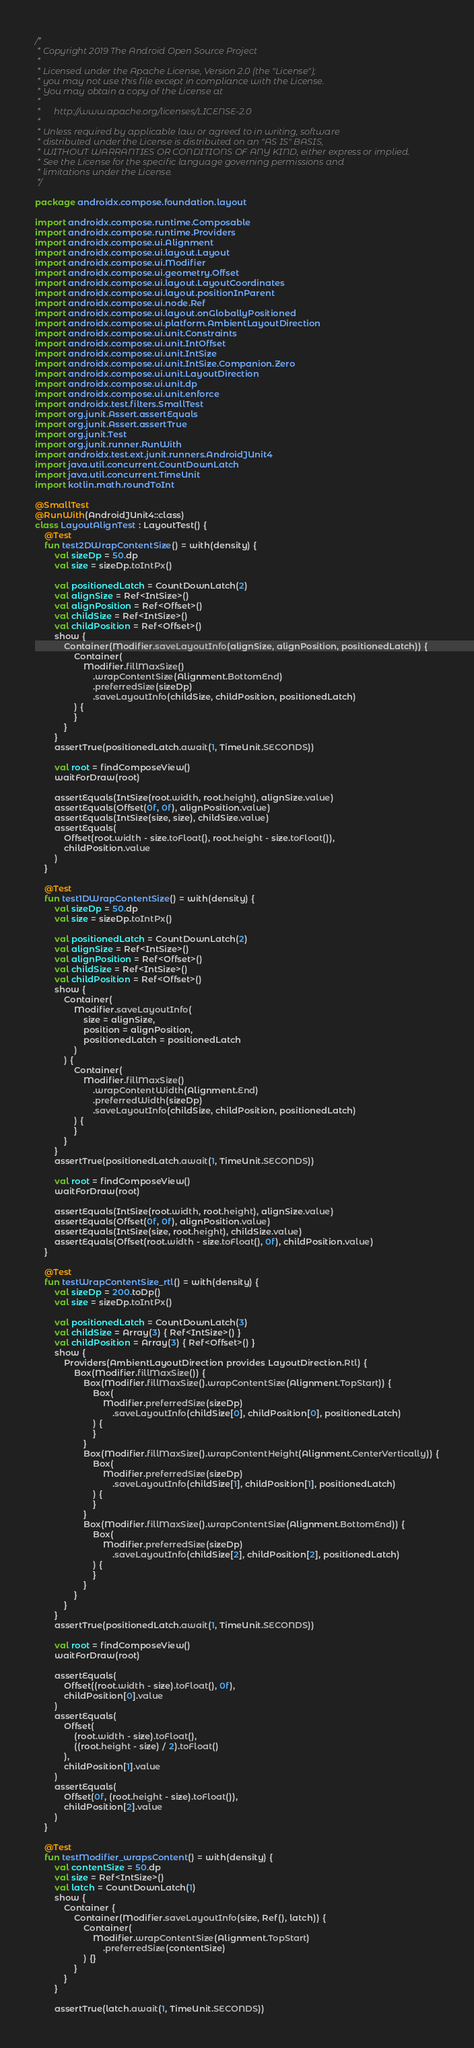<code> <loc_0><loc_0><loc_500><loc_500><_Kotlin_>/*
 * Copyright 2019 The Android Open Source Project
 *
 * Licensed under the Apache License, Version 2.0 (the "License");
 * you may not use this file except in compliance with the License.
 * You may obtain a copy of the License at
 *
 *      http://www.apache.org/licenses/LICENSE-2.0
 *
 * Unless required by applicable law or agreed to in writing, software
 * distributed under the License is distributed on an "AS IS" BASIS,
 * WITHOUT WARRANTIES OR CONDITIONS OF ANY KIND, either express or implied.
 * See the License for the specific language governing permissions and
 * limitations under the License.
 */

package androidx.compose.foundation.layout

import androidx.compose.runtime.Composable
import androidx.compose.runtime.Providers
import androidx.compose.ui.Alignment
import androidx.compose.ui.layout.Layout
import androidx.compose.ui.Modifier
import androidx.compose.ui.geometry.Offset
import androidx.compose.ui.layout.LayoutCoordinates
import androidx.compose.ui.layout.positionInParent
import androidx.compose.ui.node.Ref
import androidx.compose.ui.layout.onGloballyPositioned
import androidx.compose.ui.platform.AmbientLayoutDirection
import androidx.compose.ui.unit.Constraints
import androidx.compose.ui.unit.IntOffset
import androidx.compose.ui.unit.IntSize
import androidx.compose.ui.unit.IntSize.Companion.Zero
import androidx.compose.ui.unit.LayoutDirection
import androidx.compose.ui.unit.dp
import androidx.compose.ui.unit.enforce
import androidx.test.filters.SmallTest
import org.junit.Assert.assertEquals
import org.junit.Assert.assertTrue
import org.junit.Test
import org.junit.runner.RunWith
import androidx.test.ext.junit.runners.AndroidJUnit4
import java.util.concurrent.CountDownLatch
import java.util.concurrent.TimeUnit
import kotlin.math.roundToInt

@SmallTest
@RunWith(AndroidJUnit4::class)
class LayoutAlignTest : LayoutTest() {
    @Test
    fun test2DWrapContentSize() = with(density) {
        val sizeDp = 50.dp
        val size = sizeDp.toIntPx()

        val positionedLatch = CountDownLatch(2)
        val alignSize = Ref<IntSize>()
        val alignPosition = Ref<Offset>()
        val childSize = Ref<IntSize>()
        val childPosition = Ref<Offset>()
        show {
            Container(Modifier.saveLayoutInfo(alignSize, alignPosition, positionedLatch)) {
                Container(
                    Modifier.fillMaxSize()
                        .wrapContentSize(Alignment.BottomEnd)
                        .preferredSize(sizeDp)
                        .saveLayoutInfo(childSize, childPosition, positionedLatch)
                ) {
                }
            }
        }
        assertTrue(positionedLatch.await(1, TimeUnit.SECONDS))

        val root = findComposeView()
        waitForDraw(root)

        assertEquals(IntSize(root.width, root.height), alignSize.value)
        assertEquals(Offset(0f, 0f), alignPosition.value)
        assertEquals(IntSize(size, size), childSize.value)
        assertEquals(
            Offset(root.width - size.toFloat(), root.height - size.toFloat()),
            childPosition.value
        )
    }

    @Test
    fun test1DWrapContentSize() = with(density) {
        val sizeDp = 50.dp
        val size = sizeDp.toIntPx()

        val positionedLatch = CountDownLatch(2)
        val alignSize = Ref<IntSize>()
        val alignPosition = Ref<Offset>()
        val childSize = Ref<IntSize>()
        val childPosition = Ref<Offset>()
        show {
            Container(
                Modifier.saveLayoutInfo(
                    size = alignSize,
                    position = alignPosition,
                    positionedLatch = positionedLatch
                )
            ) {
                Container(
                    Modifier.fillMaxSize()
                        .wrapContentWidth(Alignment.End)
                        .preferredWidth(sizeDp)
                        .saveLayoutInfo(childSize, childPosition, positionedLatch)
                ) {
                }
            }
        }
        assertTrue(positionedLatch.await(1, TimeUnit.SECONDS))

        val root = findComposeView()
        waitForDraw(root)

        assertEquals(IntSize(root.width, root.height), alignSize.value)
        assertEquals(Offset(0f, 0f), alignPosition.value)
        assertEquals(IntSize(size, root.height), childSize.value)
        assertEquals(Offset(root.width - size.toFloat(), 0f), childPosition.value)
    }

    @Test
    fun testWrapContentSize_rtl() = with(density) {
        val sizeDp = 200.toDp()
        val size = sizeDp.toIntPx()

        val positionedLatch = CountDownLatch(3)
        val childSize = Array(3) { Ref<IntSize>() }
        val childPosition = Array(3) { Ref<Offset>() }
        show {
            Providers(AmbientLayoutDirection provides LayoutDirection.Rtl) {
                Box(Modifier.fillMaxSize()) {
                    Box(Modifier.fillMaxSize().wrapContentSize(Alignment.TopStart)) {
                        Box(
                            Modifier.preferredSize(sizeDp)
                                .saveLayoutInfo(childSize[0], childPosition[0], positionedLatch)
                        ) {
                        }
                    }
                    Box(Modifier.fillMaxSize().wrapContentHeight(Alignment.CenterVertically)) {
                        Box(
                            Modifier.preferredSize(sizeDp)
                                .saveLayoutInfo(childSize[1], childPosition[1], positionedLatch)
                        ) {
                        }
                    }
                    Box(Modifier.fillMaxSize().wrapContentSize(Alignment.BottomEnd)) {
                        Box(
                            Modifier.preferredSize(sizeDp)
                                .saveLayoutInfo(childSize[2], childPosition[2], positionedLatch)
                        ) {
                        }
                    }
                }
            }
        }
        assertTrue(positionedLatch.await(1, TimeUnit.SECONDS))

        val root = findComposeView()
        waitForDraw(root)

        assertEquals(
            Offset((root.width - size).toFloat(), 0f),
            childPosition[0].value
        )
        assertEquals(
            Offset(
                (root.width - size).toFloat(),
                ((root.height - size) / 2).toFloat()
            ),
            childPosition[1].value
        )
        assertEquals(
            Offset(0f, (root.height - size).toFloat()),
            childPosition[2].value
        )
    }

    @Test
    fun testModifier_wrapsContent() = with(density) {
        val contentSize = 50.dp
        val size = Ref<IntSize>()
        val latch = CountDownLatch(1)
        show {
            Container {
                Container(Modifier.saveLayoutInfo(size, Ref(), latch)) {
                    Container(
                        Modifier.wrapContentSize(Alignment.TopStart)
                            .preferredSize(contentSize)
                    ) {}
                }
            }
        }

        assertTrue(latch.await(1, TimeUnit.SECONDS))</code> 